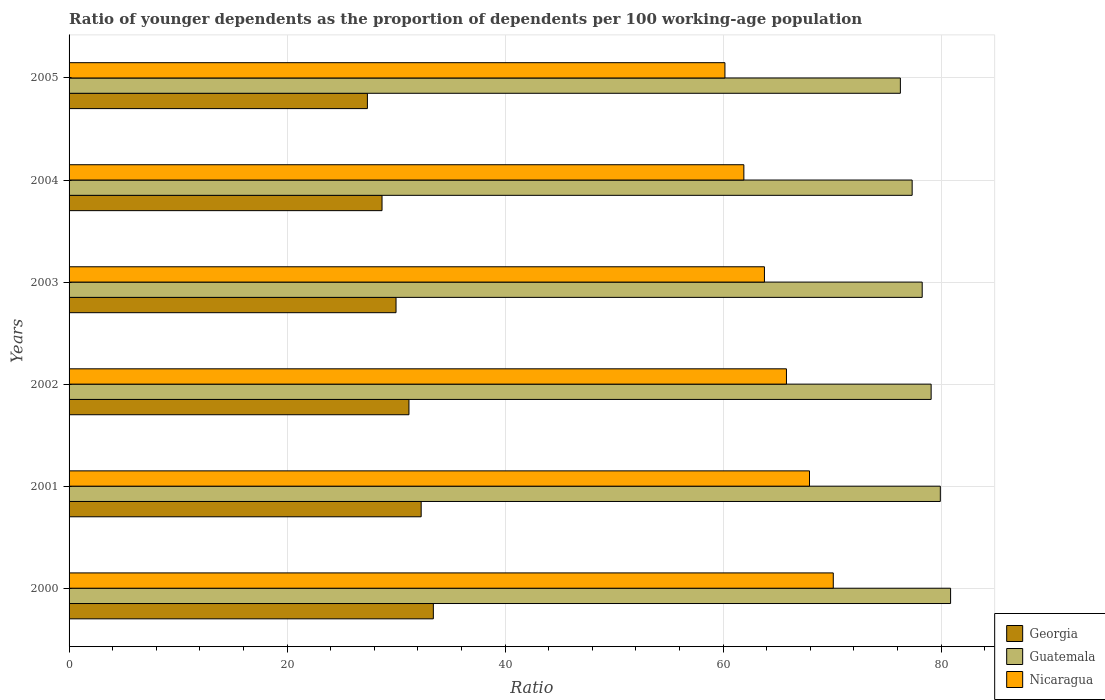How many different coloured bars are there?
Keep it short and to the point. 3. How many groups of bars are there?
Provide a succinct answer. 6. Are the number of bars per tick equal to the number of legend labels?
Ensure brevity in your answer.  Yes. How many bars are there on the 3rd tick from the top?
Provide a succinct answer. 3. How many bars are there on the 4th tick from the bottom?
Offer a very short reply. 3. In how many cases, is the number of bars for a given year not equal to the number of legend labels?
Your answer should be compact. 0. What is the age dependency ratio(young) in Georgia in 2003?
Provide a short and direct response. 29.99. Across all years, what is the maximum age dependency ratio(young) in Georgia?
Offer a terse response. 33.42. Across all years, what is the minimum age dependency ratio(young) in Georgia?
Ensure brevity in your answer.  27.37. In which year was the age dependency ratio(young) in Guatemala minimum?
Your answer should be compact. 2005. What is the total age dependency ratio(young) in Guatemala in the graph?
Give a very brief answer. 471.73. What is the difference between the age dependency ratio(young) in Georgia in 2003 and that in 2005?
Your answer should be very brief. 2.63. What is the difference between the age dependency ratio(young) in Guatemala in 2001 and the age dependency ratio(young) in Georgia in 2003?
Make the answer very short. 49.93. What is the average age dependency ratio(young) in Nicaragua per year?
Offer a very short reply. 64.95. In the year 2005, what is the difference between the age dependency ratio(young) in Nicaragua and age dependency ratio(young) in Guatemala?
Your response must be concise. -16.09. In how many years, is the age dependency ratio(young) in Georgia greater than 52 ?
Ensure brevity in your answer.  0. What is the ratio of the age dependency ratio(young) in Guatemala in 2000 to that in 2005?
Ensure brevity in your answer.  1.06. Is the age dependency ratio(young) in Georgia in 2001 less than that in 2005?
Give a very brief answer. No. What is the difference between the highest and the second highest age dependency ratio(young) in Guatemala?
Keep it short and to the point. 0.94. What is the difference between the highest and the lowest age dependency ratio(young) in Nicaragua?
Give a very brief answer. 9.94. Is the sum of the age dependency ratio(young) in Georgia in 2000 and 2005 greater than the maximum age dependency ratio(young) in Guatemala across all years?
Make the answer very short. No. What does the 2nd bar from the top in 2000 represents?
Provide a short and direct response. Guatemala. What does the 3rd bar from the bottom in 2000 represents?
Offer a very short reply. Nicaragua. Is it the case that in every year, the sum of the age dependency ratio(young) in Guatemala and age dependency ratio(young) in Georgia is greater than the age dependency ratio(young) in Nicaragua?
Your answer should be compact. Yes. What is the difference between two consecutive major ticks on the X-axis?
Ensure brevity in your answer.  20. Are the values on the major ticks of X-axis written in scientific E-notation?
Keep it short and to the point. No. Does the graph contain grids?
Ensure brevity in your answer.  Yes. What is the title of the graph?
Make the answer very short. Ratio of younger dependents as the proportion of dependents per 100 working-age population. What is the label or title of the X-axis?
Offer a terse response. Ratio. What is the Ratio of Georgia in 2000?
Your answer should be very brief. 33.42. What is the Ratio of Guatemala in 2000?
Provide a succinct answer. 80.86. What is the Ratio in Nicaragua in 2000?
Your answer should be very brief. 70.1. What is the Ratio of Georgia in 2001?
Your response must be concise. 32.3. What is the Ratio in Guatemala in 2001?
Keep it short and to the point. 79.92. What is the Ratio in Nicaragua in 2001?
Your response must be concise. 67.92. What is the Ratio of Georgia in 2002?
Keep it short and to the point. 31.18. What is the Ratio of Guatemala in 2002?
Offer a terse response. 79.08. What is the Ratio in Nicaragua in 2002?
Ensure brevity in your answer.  65.81. What is the Ratio in Georgia in 2003?
Offer a very short reply. 29.99. What is the Ratio of Guatemala in 2003?
Ensure brevity in your answer.  78.26. What is the Ratio of Nicaragua in 2003?
Keep it short and to the point. 63.79. What is the Ratio in Georgia in 2004?
Keep it short and to the point. 28.71. What is the Ratio in Guatemala in 2004?
Give a very brief answer. 77.34. What is the Ratio of Nicaragua in 2004?
Provide a succinct answer. 61.9. What is the Ratio of Georgia in 2005?
Provide a short and direct response. 27.37. What is the Ratio in Guatemala in 2005?
Keep it short and to the point. 76.26. What is the Ratio in Nicaragua in 2005?
Keep it short and to the point. 60.17. Across all years, what is the maximum Ratio in Georgia?
Your answer should be very brief. 33.42. Across all years, what is the maximum Ratio in Guatemala?
Your answer should be compact. 80.86. Across all years, what is the maximum Ratio in Nicaragua?
Make the answer very short. 70.1. Across all years, what is the minimum Ratio in Georgia?
Provide a short and direct response. 27.37. Across all years, what is the minimum Ratio of Guatemala?
Provide a short and direct response. 76.26. Across all years, what is the minimum Ratio in Nicaragua?
Offer a very short reply. 60.17. What is the total Ratio of Georgia in the graph?
Provide a short and direct response. 182.96. What is the total Ratio in Guatemala in the graph?
Keep it short and to the point. 471.73. What is the total Ratio of Nicaragua in the graph?
Your answer should be compact. 389.69. What is the difference between the Ratio in Georgia in 2000 and that in 2001?
Offer a terse response. 1.12. What is the difference between the Ratio in Guatemala in 2000 and that in 2001?
Give a very brief answer. 0.94. What is the difference between the Ratio in Nicaragua in 2000 and that in 2001?
Offer a very short reply. 2.18. What is the difference between the Ratio of Georgia in 2000 and that in 2002?
Your response must be concise. 2.24. What is the difference between the Ratio of Guatemala in 2000 and that in 2002?
Provide a succinct answer. 1.78. What is the difference between the Ratio of Nicaragua in 2000 and that in 2002?
Your answer should be compact. 4.29. What is the difference between the Ratio of Georgia in 2000 and that in 2003?
Make the answer very short. 3.42. What is the difference between the Ratio in Guatemala in 2000 and that in 2003?
Provide a short and direct response. 2.6. What is the difference between the Ratio of Nicaragua in 2000 and that in 2003?
Offer a terse response. 6.31. What is the difference between the Ratio in Georgia in 2000 and that in 2004?
Provide a succinct answer. 4.71. What is the difference between the Ratio of Guatemala in 2000 and that in 2004?
Make the answer very short. 3.53. What is the difference between the Ratio in Nicaragua in 2000 and that in 2004?
Provide a short and direct response. 8.2. What is the difference between the Ratio in Georgia in 2000 and that in 2005?
Give a very brief answer. 6.05. What is the difference between the Ratio of Guatemala in 2000 and that in 2005?
Provide a short and direct response. 4.61. What is the difference between the Ratio of Nicaragua in 2000 and that in 2005?
Make the answer very short. 9.94. What is the difference between the Ratio in Georgia in 2001 and that in 2002?
Ensure brevity in your answer.  1.12. What is the difference between the Ratio in Guatemala in 2001 and that in 2002?
Give a very brief answer. 0.84. What is the difference between the Ratio in Nicaragua in 2001 and that in 2002?
Offer a terse response. 2.11. What is the difference between the Ratio in Georgia in 2001 and that in 2003?
Offer a terse response. 2.31. What is the difference between the Ratio in Guatemala in 2001 and that in 2003?
Offer a very short reply. 1.66. What is the difference between the Ratio of Nicaragua in 2001 and that in 2003?
Your answer should be very brief. 4.13. What is the difference between the Ratio in Georgia in 2001 and that in 2004?
Offer a very short reply. 3.59. What is the difference between the Ratio of Guatemala in 2001 and that in 2004?
Your response must be concise. 2.58. What is the difference between the Ratio in Nicaragua in 2001 and that in 2004?
Make the answer very short. 6.02. What is the difference between the Ratio in Georgia in 2001 and that in 2005?
Provide a short and direct response. 4.93. What is the difference between the Ratio in Guatemala in 2001 and that in 2005?
Provide a succinct answer. 3.67. What is the difference between the Ratio of Nicaragua in 2001 and that in 2005?
Offer a terse response. 7.76. What is the difference between the Ratio of Georgia in 2002 and that in 2003?
Offer a very short reply. 1.19. What is the difference between the Ratio in Guatemala in 2002 and that in 2003?
Ensure brevity in your answer.  0.82. What is the difference between the Ratio in Nicaragua in 2002 and that in 2003?
Your response must be concise. 2.02. What is the difference between the Ratio in Georgia in 2002 and that in 2004?
Provide a succinct answer. 2.47. What is the difference between the Ratio in Guatemala in 2002 and that in 2004?
Keep it short and to the point. 1.74. What is the difference between the Ratio in Nicaragua in 2002 and that in 2004?
Your answer should be compact. 3.91. What is the difference between the Ratio of Georgia in 2002 and that in 2005?
Provide a succinct answer. 3.81. What is the difference between the Ratio in Guatemala in 2002 and that in 2005?
Your answer should be compact. 2.82. What is the difference between the Ratio in Nicaragua in 2002 and that in 2005?
Provide a succinct answer. 5.64. What is the difference between the Ratio of Georgia in 2003 and that in 2004?
Ensure brevity in your answer.  1.28. What is the difference between the Ratio in Guatemala in 2003 and that in 2004?
Make the answer very short. 0.92. What is the difference between the Ratio of Nicaragua in 2003 and that in 2004?
Your answer should be very brief. 1.89. What is the difference between the Ratio of Georgia in 2003 and that in 2005?
Provide a short and direct response. 2.63. What is the difference between the Ratio of Guatemala in 2003 and that in 2005?
Provide a short and direct response. 2. What is the difference between the Ratio of Nicaragua in 2003 and that in 2005?
Provide a short and direct response. 3.62. What is the difference between the Ratio in Georgia in 2004 and that in 2005?
Provide a succinct answer. 1.34. What is the difference between the Ratio of Guatemala in 2004 and that in 2005?
Give a very brief answer. 1.08. What is the difference between the Ratio of Nicaragua in 2004 and that in 2005?
Offer a very short reply. 1.74. What is the difference between the Ratio of Georgia in 2000 and the Ratio of Guatemala in 2001?
Keep it short and to the point. -46.51. What is the difference between the Ratio in Georgia in 2000 and the Ratio in Nicaragua in 2001?
Your answer should be compact. -34.51. What is the difference between the Ratio of Guatemala in 2000 and the Ratio of Nicaragua in 2001?
Your response must be concise. 12.94. What is the difference between the Ratio of Georgia in 2000 and the Ratio of Guatemala in 2002?
Offer a terse response. -45.66. What is the difference between the Ratio of Georgia in 2000 and the Ratio of Nicaragua in 2002?
Your response must be concise. -32.39. What is the difference between the Ratio of Guatemala in 2000 and the Ratio of Nicaragua in 2002?
Your answer should be compact. 15.06. What is the difference between the Ratio of Georgia in 2000 and the Ratio of Guatemala in 2003?
Your answer should be compact. -44.84. What is the difference between the Ratio of Georgia in 2000 and the Ratio of Nicaragua in 2003?
Make the answer very short. -30.37. What is the difference between the Ratio of Guatemala in 2000 and the Ratio of Nicaragua in 2003?
Provide a short and direct response. 17.08. What is the difference between the Ratio of Georgia in 2000 and the Ratio of Guatemala in 2004?
Offer a terse response. -43.92. What is the difference between the Ratio in Georgia in 2000 and the Ratio in Nicaragua in 2004?
Offer a very short reply. -28.49. What is the difference between the Ratio in Guatemala in 2000 and the Ratio in Nicaragua in 2004?
Offer a terse response. 18.96. What is the difference between the Ratio in Georgia in 2000 and the Ratio in Guatemala in 2005?
Provide a short and direct response. -42.84. What is the difference between the Ratio of Georgia in 2000 and the Ratio of Nicaragua in 2005?
Keep it short and to the point. -26.75. What is the difference between the Ratio of Guatemala in 2000 and the Ratio of Nicaragua in 2005?
Provide a short and direct response. 20.7. What is the difference between the Ratio of Georgia in 2001 and the Ratio of Guatemala in 2002?
Give a very brief answer. -46.78. What is the difference between the Ratio of Georgia in 2001 and the Ratio of Nicaragua in 2002?
Provide a succinct answer. -33.51. What is the difference between the Ratio in Guatemala in 2001 and the Ratio in Nicaragua in 2002?
Your answer should be compact. 14.11. What is the difference between the Ratio of Georgia in 2001 and the Ratio of Guatemala in 2003?
Provide a short and direct response. -45.96. What is the difference between the Ratio in Georgia in 2001 and the Ratio in Nicaragua in 2003?
Your answer should be very brief. -31.49. What is the difference between the Ratio of Guatemala in 2001 and the Ratio of Nicaragua in 2003?
Make the answer very short. 16.14. What is the difference between the Ratio in Georgia in 2001 and the Ratio in Guatemala in 2004?
Offer a terse response. -45.04. What is the difference between the Ratio in Georgia in 2001 and the Ratio in Nicaragua in 2004?
Give a very brief answer. -29.6. What is the difference between the Ratio of Guatemala in 2001 and the Ratio of Nicaragua in 2004?
Your answer should be compact. 18.02. What is the difference between the Ratio of Georgia in 2001 and the Ratio of Guatemala in 2005?
Ensure brevity in your answer.  -43.96. What is the difference between the Ratio in Georgia in 2001 and the Ratio in Nicaragua in 2005?
Your response must be concise. -27.87. What is the difference between the Ratio in Guatemala in 2001 and the Ratio in Nicaragua in 2005?
Offer a very short reply. 19.76. What is the difference between the Ratio in Georgia in 2002 and the Ratio in Guatemala in 2003?
Make the answer very short. -47.08. What is the difference between the Ratio in Georgia in 2002 and the Ratio in Nicaragua in 2003?
Keep it short and to the point. -32.61. What is the difference between the Ratio in Guatemala in 2002 and the Ratio in Nicaragua in 2003?
Ensure brevity in your answer.  15.29. What is the difference between the Ratio of Georgia in 2002 and the Ratio of Guatemala in 2004?
Give a very brief answer. -46.16. What is the difference between the Ratio of Georgia in 2002 and the Ratio of Nicaragua in 2004?
Give a very brief answer. -30.72. What is the difference between the Ratio of Guatemala in 2002 and the Ratio of Nicaragua in 2004?
Your answer should be very brief. 17.18. What is the difference between the Ratio of Georgia in 2002 and the Ratio of Guatemala in 2005?
Your answer should be compact. -45.08. What is the difference between the Ratio in Georgia in 2002 and the Ratio in Nicaragua in 2005?
Keep it short and to the point. -28.99. What is the difference between the Ratio in Guatemala in 2002 and the Ratio in Nicaragua in 2005?
Give a very brief answer. 18.91. What is the difference between the Ratio of Georgia in 2003 and the Ratio of Guatemala in 2004?
Your answer should be compact. -47.35. What is the difference between the Ratio of Georgia in 2003 and the Ratio of Nicaragua in 2004?
Your answer should be compact. -31.91. What is the difference between the Ratio in Guatemala in 2003 and the Ratio in Nicaragua in 2004?
Give a very brief answer. 16.36. What is the difference between the Ratio of Georgia in 2003 and the Ratio of Guatemala in 2005?
Make the answer very short. -46.27. What is the difference between the Ratio of Georgia in 2003 and the Ratio of Nicaragua in 2005?
Give a very brief answer. -30.17. What is the difference between the Ratio in Guatemala in 2003 and the Ratio in Nicaragua in 2005?
Provide a short and direct response. 18.09. What is the difference between the Ratio in Georgia in 2004 and the Ratio in Guatemala in 2005?
Offer a very short reply. -47.55. What is the difference between the Ratio in Georgia in 2004 and the Ratio in Nicaragua in 2005?
Your answer should be compact. -31.46. What is the difference between the Ratio of Guatemala in 2004 and the Ratio of Nicaragua in 2005?
Your answer should be compact. 17.17. What is the average Ratio of Georgia per year?
Provide a succinct answer. 30.49. What is the average Ratio of Guatemala per year?
Your response must be concise. 78.62. What is the average Ratio of Nicaragua per year?
Offer a very short reply. 64.95. In the year 2000, what is the difference between the Ratio of Georgia and Ratio of Guatemala?
Ensure brevity in your answer.  -47.45. In the year 2000, what is the difference between the Ratio of Georgia and Ratio of Nicaragua?
Ensure brevity in your answer.  -36.69. In the year 2000, what is the difference between the Ratio of Guatemala and Ratio of Nicaragua?
Keep it short and to the point. 10.76. In the year 2001, what is the difference between the Ratio of Georgia and Ratio of Guatemala?
Offer a very short reply. -47.62. In the year 2001, what is the difference between the Ratio of Georgia and Ratio of Nicaragua?
Provide a short and direct response. -35.62. In the year 2001, what is the difference between the Ratio in Guatemala and Ratio in Nicaragua?
Your answer should be compact. 12. In the year 2002, what is the difference between the Ratio of Georgia and Ratio of Guatemala?
Your answer should be very brief. -47.9. In the year 2002, what is the difference between the Ratio of Georgia and Ratio of Nicaragua?
Offer a terse response. -34.63. In the year 2002, what is the difference between the Ratio of Guatemala and Ratio of Nicaragua?
Give a very brief answer. 13.27. In the year 2003, what is the difference between the Ratio of Georgia and Ratio of Guatemala?
Ensure brevity in your answer.  -48.27. In the year 2003, what is the difference between the Ratio of Georgia and Ratio of Nicaragua?
Provide a short and direct response. -33.8. In the year 2003, what is the difference between the Ratio in Guatemala and Ratio in Nicaragua?
Offer a terse response. 14.47. In the year 2004, what is the difference between the Ratio in Georgia and Ratio in Guatemala?
Give a very brief answer. -48.63. In the year 2004, what is the difference between the Ratio in Georgia and Ratio in Nicaragua?
Ensure brevity in your answer.  -33.19. In the year 2004, what is the difference between the Ratio of Guatemala and Ratio of Nicaragua?
Offer a very short reply. 15.44. In the year 2005, what is the difference between the Ratio in Georgia and Ratio in Guatemala?
Your answer should be very brief. -48.89. In the year 2005, what is the difference between the Ratio of Georgia and Ratio of Nicaragua?
Provide a short and direct response. -32.8. In the year 2005, what is the difference between the Ratio in Guatemala and Ratio in Nicaragua?
Your answer should be compact. 16.09. What is the ratio of the Ratio in Georgia in 2000 to that in 2001?
Keep it short and to the point. 1.03. What is the ratio of the Ratio of Guatemala in 2000 to that in 2001?
Your response must be concise. 1.01. What is the ratio of the Ratio in Nicaragua in 2000 to that in 2001?
Provide a short and direct response. 1.03. What is the ratio of the Ratio of Georgia in 2000 to that in 2002?
Your answer should be compact. 1.07. What is the ratio of the Ratio of Guatemala in 2000 to that in 2002?
Give a very brief answer. 1.02. What is the ratio of the Ratio in Nicaragua in 2000 to that in 2002?
Provide a short and direct response. 1.07. What is the ratio of the Ratio in Georgia in 2000 to that in 2003?
Provide a succinct answer. 1.11. What is the ratio of the Ratio of Nicaragua in 2000 to that in 2003?
Provide a succinct answer. 1.1. What is the ratio of the Ratio in Georgia in 2000 to that in 2004?
Keep it short and to the point. 1.16. What is the ratio of the Ratio of Guatemala in 2000 to that in 2004?
Your answer should be very brief. 1.05. What is the ratio of the Ratio in Nicaragua in 2000 to that in 2004?
Offer a very short reply. 1.13. What is the ratio of the Ratio in Georgia in 2000 to that in 2005?
Give a very brief answer. 1.22. What is the ratio of the Ratio in Guatemala in 2000 to that in 2005?
Provide a short and direct response. 1.06. What is the ratio of the Ratio of Nicaragua in 2000 to that in 2005?
Make the answer very short. 1.17. What is the ratio of the Ratio in Georgia in 2001 to that in 2002?
Ensure brevity in your answer.  1.04. What is the ratio of the Ratio of Guatemala in 2001 to that in 2002?
Make the answer very short. 1.01. What is the ratio of the Ratio in Nicaragua in 2001 to that in 2002?
Give a very brief answer. 1.03. What is the ratio of the Ratio of Guatemala in 2001 to that in 2003?
Your answer should be very brief. 1.02. What is the ratio of the Ratio of Nicaragua in 2001 to that in 2003?
Your answer should be compact. 1.06. What is the ratio of the Ratio of Georgia in 2001 to that in 2004?
Your answer should be very brief. 1.13. What is the ratio of the Ratio in Guatemala in 2001 to that in 2004?
Provide a short and direct response. 1.03. What is the ratio of the Ratio in Nicaragua in 2001 to that in 2004?
Make the answer very short. 1.1. What is the ratio of the Ratio in Georgia in 2001 to that in 2005?
Offer a very short reply. 1.18. What is the ratio of the Ratio of Guatemala in 2001 to that in 2005?
Offer a terse response. 1.05. What is the ratio of the Ratio of Nicaragua in 2001 to that in 2005?
Offer a terse response. 1.13. What is the ratio of the Ratio in Georgia in 2002 to that in 2003?
Ensure brevity in your answer.  1.04. What is the ratio of the Ratio of Guatemala in 2002 to that in 2003?
Your answer should be compact. 1.01. What is the ratio of the Ratio of Nicaragua in 2002 to that in 2003?
Provide a succinct answer. 1.03. What is the ratio of the Ratio of Georgia in 2002 to that in 2004?
Keep it short and to the point. 1.09. What is the ratio of the Ratio in Guatemala in 2002 to that in 2004?
Provide a succinct answer. 1.02. What is the ratio of the Ratio of Nicaragua in 2002 to that in 2004?
Your response must be concise. 1.06. What is the ratio of the Ratio in Georgia in 2002 to that in 2005?
Make the answer very short. 1.14. What is the ratio of the Ratio of Guatemala in 2002 to that in 2005?
Ensure brevity in your answer.  1.04. What is the ratio of the Ratio in Nicaragua in 2002 to that in 2005?
Keep it short and to the point. 1.09. What is the ratio of the Ratio of Georgia in 2003 to that in 2004?
Ensure brevity in your answer.  1.04. What is the ratio of the Ratio in Guatemala in 2003 to that in 2004?
Keep it short and to the point. 1.01. What is the ratio of the Ratio in Nicaragua in 2003 to that in 2004?
Offer a terse response. 1.03. What is the ratio of the Ratio in Georgia in 2003 to that in 2005?
Keep it short and to the point. 1.1. What is the ratio of the Ratio in Guatemala in 2003 to that in 2005?
Offer a very short reply. 1.03. What is the ratio of the Ratio of Nicaragua in 2003 to that in 2005?
Your response must be concise. 1.06. What is the ratio of the Ratio of Georgia in 2004 to that in 2005?
Offer a very short reply. 1.05. What is the ratio of the Ratio in Guatemala in 2004 to that in 2005?
Offer a terse response. 1.01. What is the ratio of the Ratio of Nicaragua in 2004 to that in 2005?
Provide a succinct answer. 1.03. What is the difference between the highest and the second highest Ratio of Georgia?
Offer a very short reply. 1.12. What is the difference between the highest and the second highest Ratio of Guatemala?
Provide a short and direct response. 0.94. What is the difference between the highest and the second highest Ratio in Nicaragua?
Provide a short and direct response. 2.18. What is the difference between the highest and the lowest Ratio in Georgia?
Give a very brief answer. 6.05. What is the difference between the highest and the lowest Ratio in Guatemala?
Provide a short and direct response. 4.61. What is the difference between the highest and the lowest Ratio in Nicaragua?
Provide a short and direct response. 9.94. 